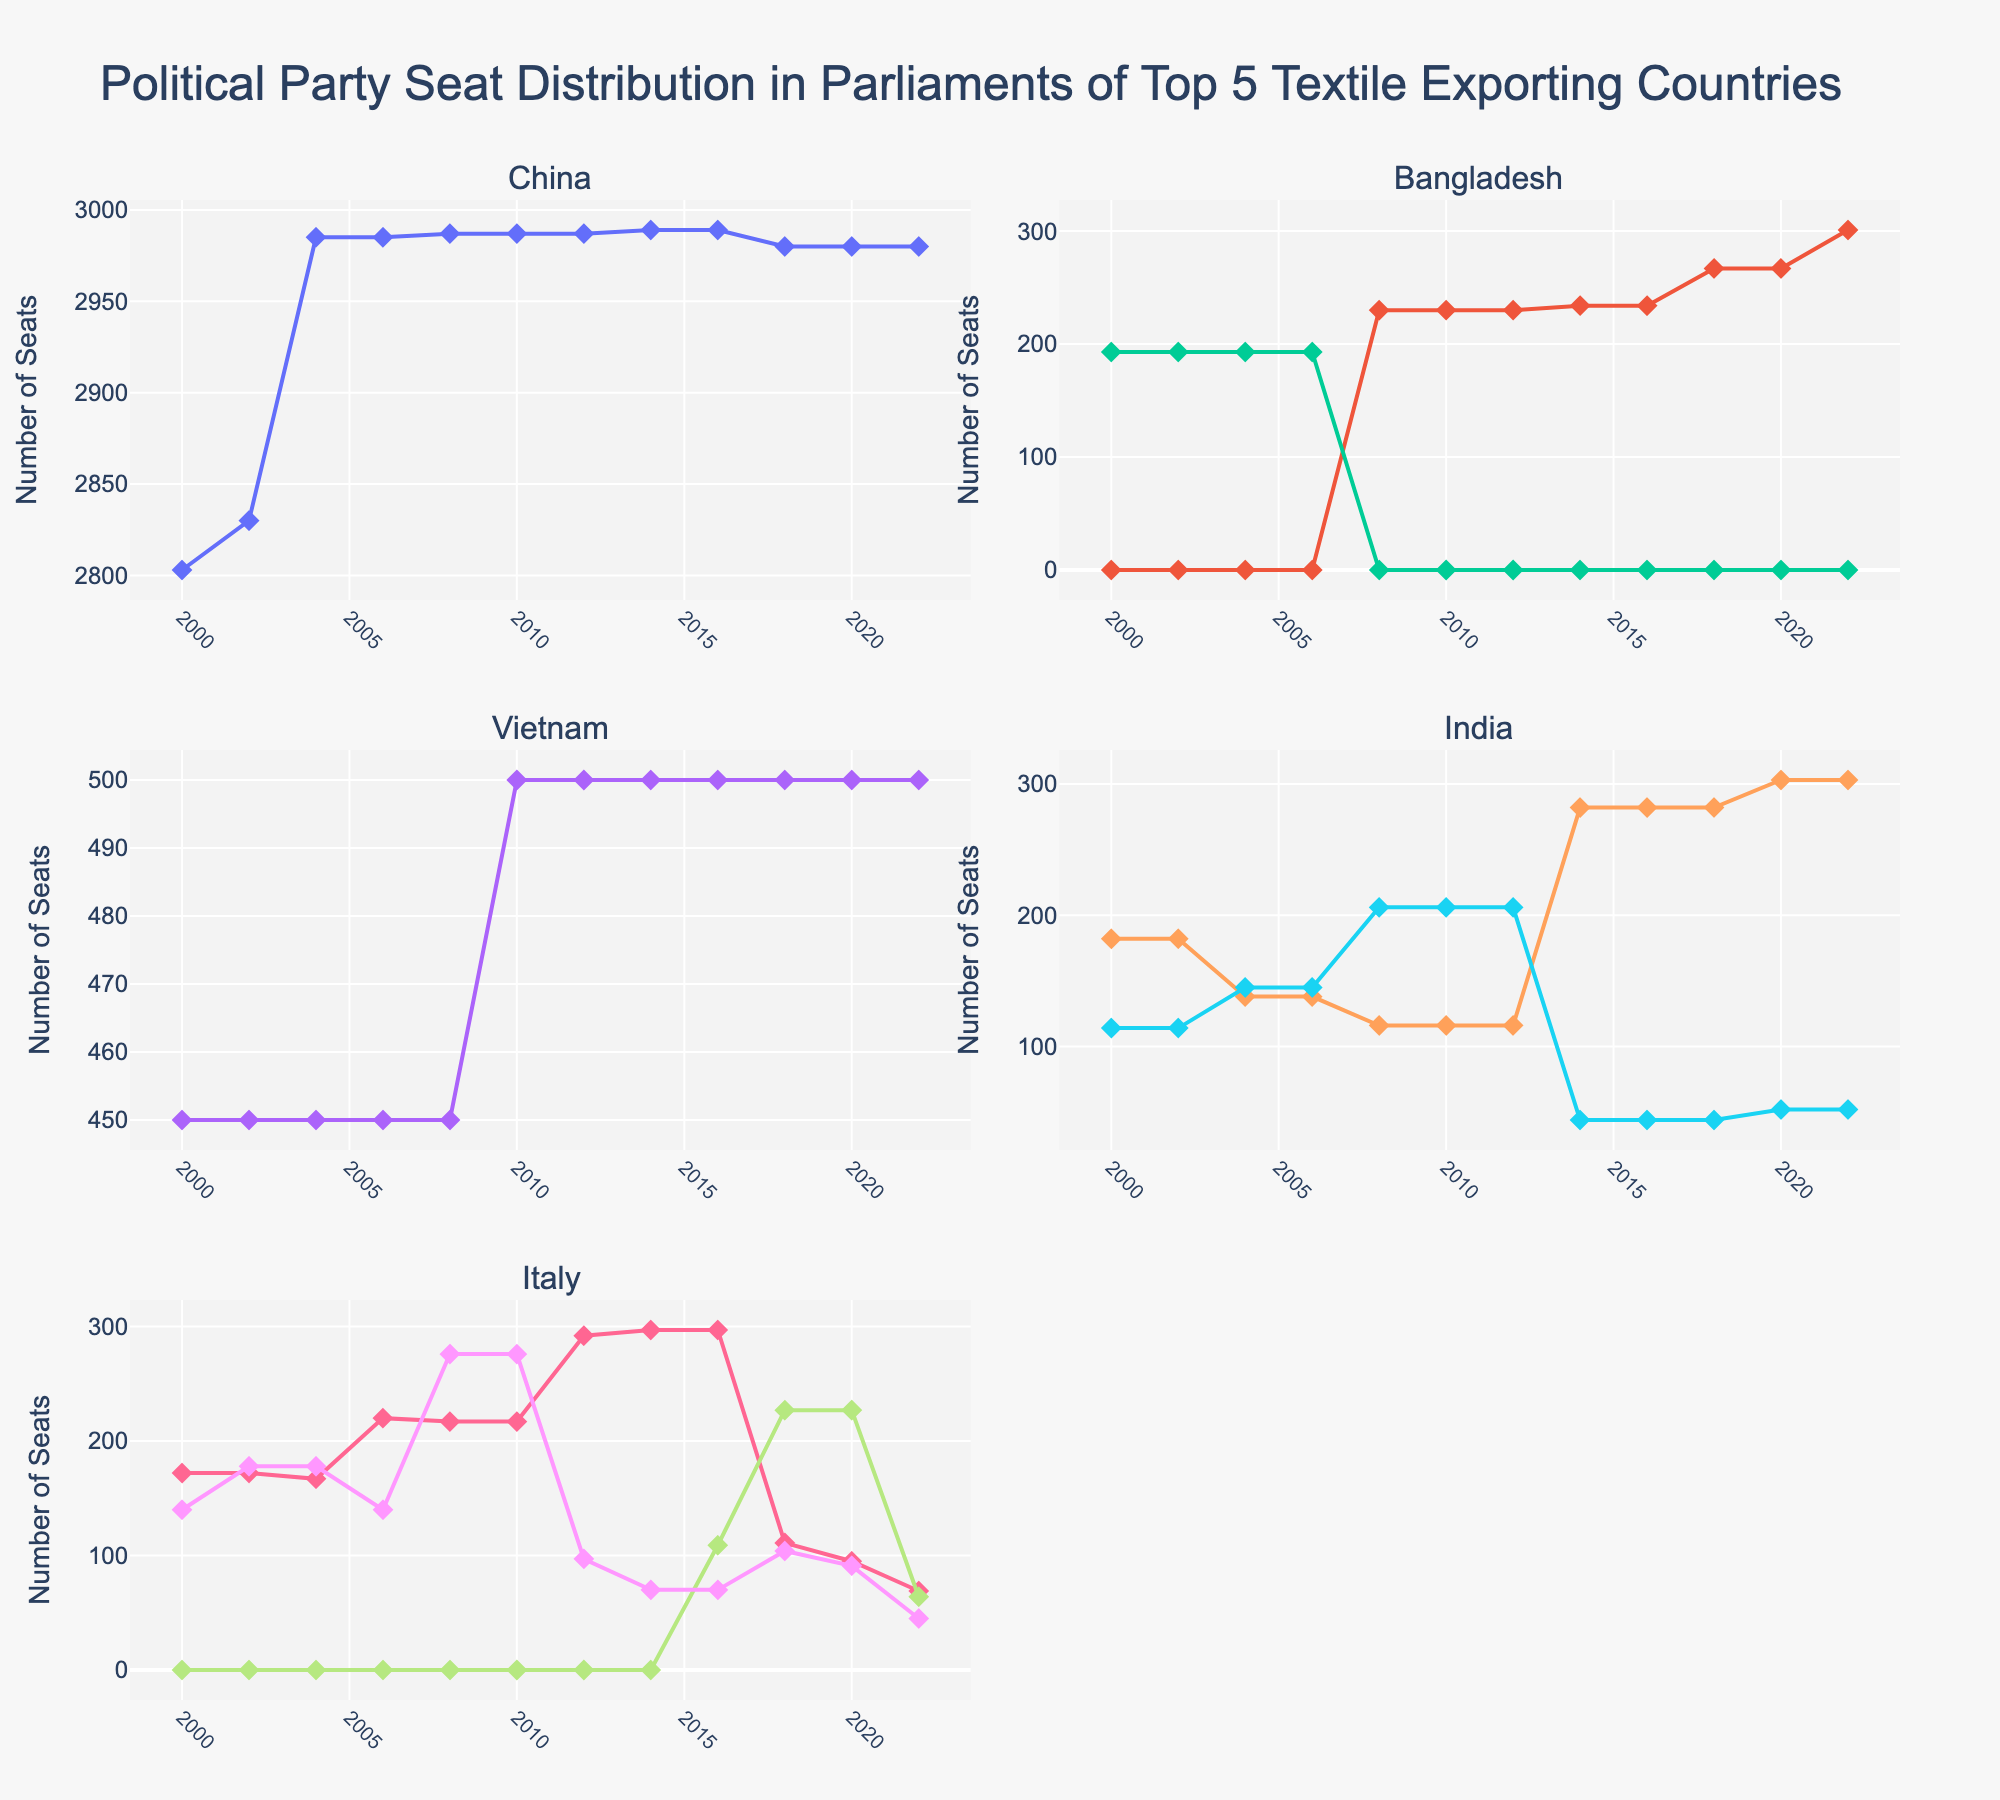Which country has the highest number of seats for a given party in 2022? In 2022, we need to observe the endpoints of each line for each country's parties. China has the most at 2980 CPP seats.
Answer: China Which party in Italy saw the most significant change in seats from 2000 to 2022? Calculate the difference in seats for each Italian party between 2000 and 2022. The Democratic party's seats changed from 172 to 69, a decrease of 103.
Answer: Democratic By how much did the CCP's seats in China increase from 2000 to 2022? Observe the endpoints of the CCP line in China’s subplot. The seats increased from 2803 in 2000 to 2980 in 2022. The change is 2980 - 2803 = 177.
Answer: 177 Between BJP and INC in India, which party gained more seats from 2000 to 2014? Calculate the seat change for BJP and INC. BJP increased from 182 to 282 (100 seats), while INC decreased from 114 to 44 (-70). BJP gained more seats.
Answer: BJP Which country shows the least variation in political party seat distribution over the years? By visual inspection, Vietnam's CPV line remains steady at 450-500 seats, showing minimal variation compared to slight changes in other countries.
Answer: Vietnam What is the approximate average number of seats held by the Bangladesh AL party from 2008 to 2022? Sum the seats for Bangladesh AL from 2008 to 2022 and divide by the number of years (6 periods). (230+230+230+234+234+267+267+301)/8 ≈ 249.1
Answer: 249 In which year did the Five Star Movement (Italy) first achieve seats, and how many did they have? Observing Italy's subplot, the Five Star Movement first appears in 2018 with 227 seats.
Answer: 2018, 227 Compare the seat distribution trend of the CPV in Vietnam and the AL in Bangladesh from 2008 to 2022. CPV in Vietnam remains constant at 500 seats. AL in Bangladesh increases from 230 to 301. AL shows an increasing trend, unlike flat CPV.
Answer: AL increasing, CPV constant How many seats did the BNP in Bangladesh hold after 2004? Post-2004, BNP remains at 0 seats as confirmed by visual inspection of Bangladesh subplots.
Answer: 0 What is the combined total number of seats held by BJP and INC in India in 2008 and 2022? Add seats for BJP and INC in both years. For 2008: 116 (BJP) + 206 (INC) = 322. For 2022: 303 (BJP) + 52 (INC) = 355.
Answer: 322 in 2008, 355 in 2022 